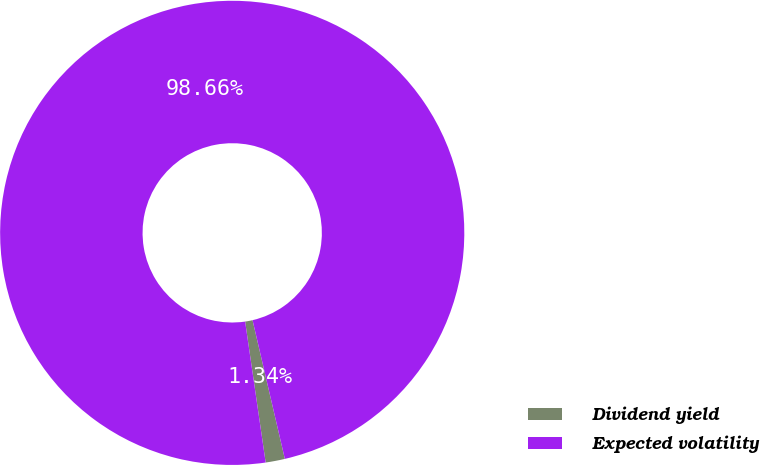Convert chart to OTSL. <chart><loc_0><loc_0><loc_500><loc_500><pie_chart><fcel>Dividend yield<fcel>Expected volatility<nl><fcel>1.34%<fcel>98.66%<nl></chart> 